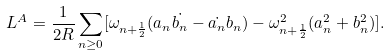<formula> <loc_0><loc_0><loc_500><loc_500>L ^ { A } = \frac { 1 } { 2 R } \sum _ { n \geq 0 } [ \omega _ { n + \frac { 1 } { 2 } } ( a _ { n } \dot { b _ { n } } - \dot { a _ { n } } b _ { n } ) - \omega _ { n + \frac { 1 } { 2 } } ^ { 2 } ( a _ { n } ^ { 2 } + b _ { n } ^ { 2 } ) ] .</formula> 